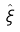<formula> <loc_0><loc_0><loc_500><loc_500>\hat { \xi }</formula> 